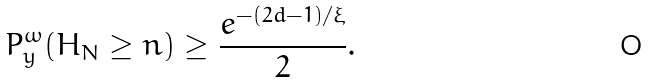Convert formula to latex. <formula><loc_0><loc_0><loc_500><loc_500>P ^ { \omega } _ { y } ( H _ { N } \geq n ) \geq \frac { e ^ { - ( 2 d - 1 ) / \xi } } { 2 } .</formula> 